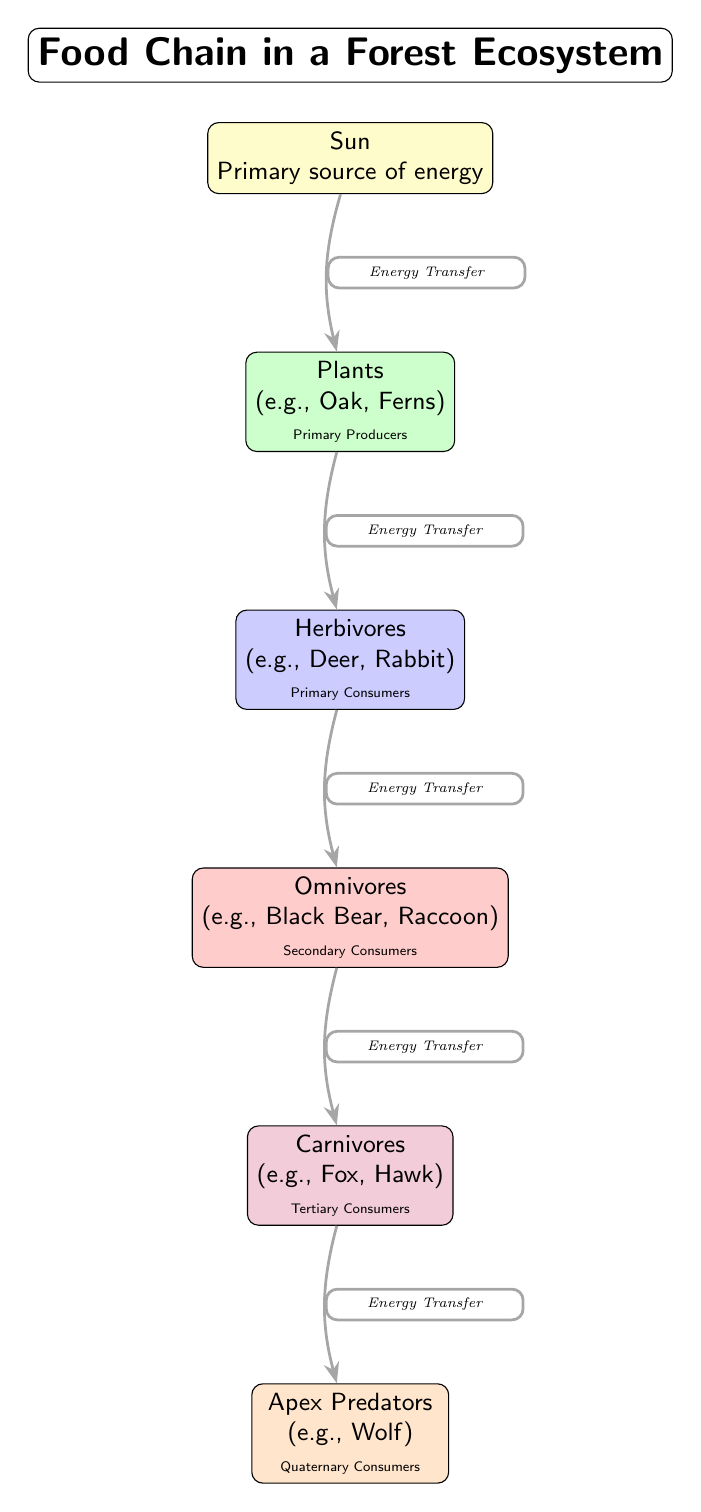What's the primary source of energy in this food chain? The diagram identifies the "Sun" as the primary source of energy, placed at the top of the food chain.
Answer: Sun How many levels are in the food chain? The diagram shows a total of six distinct levels, starting from the primary producers down to the apex predators.
Answer: Six What type of organisms are classified as primary producers? The diagram specifies "Plants" such as "Oak" and "Ferns" as the primary producers at the second level.
Answer: Plants Which trophic level do omnivores occupy? According to the diagram, omnivores are positioned at the fourth level, indicating their role as secondary consumers.
Answer: Fourth What is the relationship between herbivores and omnivores? The diagram illustrates an energy transfer relationship flowing from herbivores to omnivores, indicating that omnivores consume herbivores.
Answer: Energy Transfer Who are the apex predators in this food chain? In the diagram, apex predators are represented by "Wolves," which are located at the sixth and highest level of the food chain.
Answer: Wolf What are the primary consumers in this forest ecosystem? The diagram indicates "Herbivores," such as "Deer" and "Rabbit," as the primary consumers found at the third level.
Answer: Herbivores How do carnivores obtain energy? The diagram shows that energy transfer flows from omnivores to carnivores, indicating that carnivores gain energy by consuming omnivores.
Answer: Energy Transfer What type of organisms are found at the tertiary consumers level? The diagram specifies "Carnivores," such as "Fox" and "Hawk," as the organisms located at the fifth level of the food chain.
Answer: Carnivores 